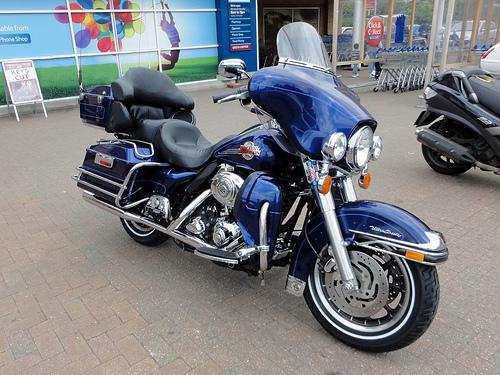Question: what color is the motorcycles?
Choices:
A. Black.
B. Red.
C. White.
D. Blue.
Answer with the letter. Answer: D Question: why is there a headlight?
Choices:
A. To see through the fog.
B. To drive during the day.
C. To drive when it's dark.
D. To see through snow.
Answer with the letter. Answer: C Question: what are the tires made of?
Choices:
A. Glass.
B. Rubber.
C. Wood.
D. Paper.
Answer with the letter. Answer: B 